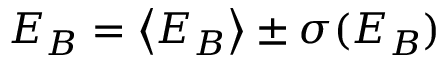<formula> <loc_0><loc_0><loc_500><loc_500>E _ { B } = \left < E _ { B } \right > \pm \sigma ( E _ { B } )</formula> 